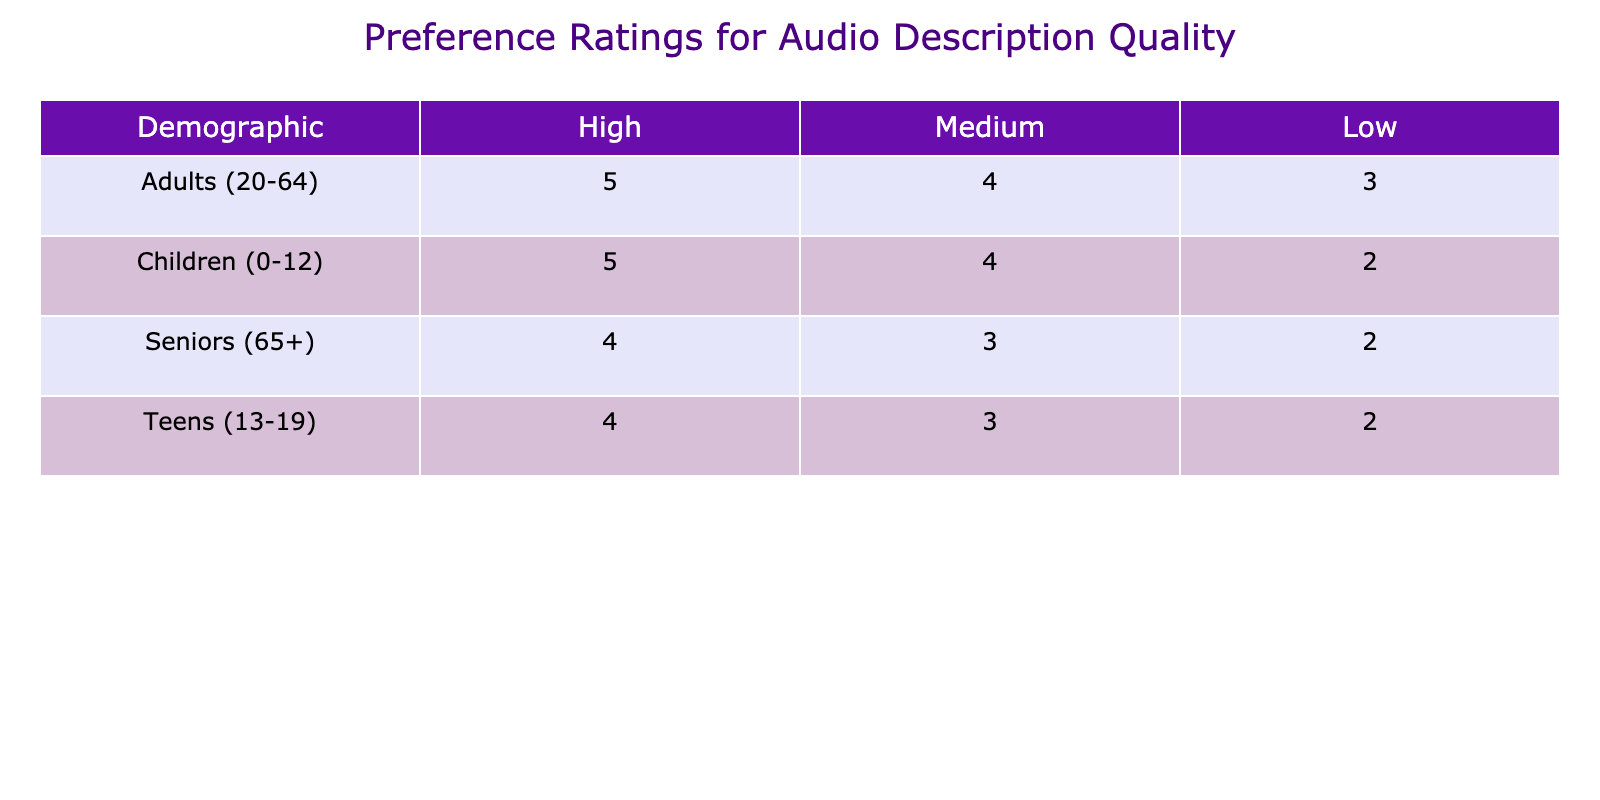What is the preference rating for audio description quality considered high among children? According to the table, for the demographic of children, the preference rating for audio description quality categorized as high is 5.
Answer: 5 What is the lowest preference rating recorded for audio description quality in the seniors' demographic? In the table, the lowest preference rating for audio description quality among seniors is listed under the low category, which is 2.
Answer: 2 What is the average preference rating for audio description quality across all audio description quality levels for adults aged 20-64? To find the average preference rating for adults, we add the relevant ratings: High (5) + Medium (4) + Low (3) = 12. There are 3 ratings, so we divide 12 by 3, resulting in an average of 4.
Answer: 4 Is the preference rating for high audio description quality lower for teens than for adults? The preference rating for high audio description quality for teens is 4, while for adults, it is 5. Since 4 is less than 5, the statement is true.
Answer: Yes What is the difference in preference ratings between medium and low audio description quality for children? For children, the preference rating for medium is 4, and for low is 2. The difference is 4 - 2 = 2.
Answer: 2 Which demographic has the highest preference rating for audio description quality at the medium level? In reviewing the table, adults aged 20-64 have a preference rating of 4 for medium audio description quality, which is higher than the corresponding ratings in other demographics (Children: 4, Teens: 3, Seniors: 3).
Answer: Adults (20-64) What is the sum of preference ratings for low audio description quality across all demographics? From the table, the ratings for low audio description quality are 2 (children) + 2 (teens) + 3 (adults) + 2 (seniors) = 9.
Answer: 9 What percentage of the highest possible preference rating (which is 5) does the medium preference rating have for seniors? The medium preference rating for seniors is 3. To find the percentage of the highest rating, we calculate (3 / 5) * 100, resulting in 60%.
Answer: 60% Is there any demographic where the preference rating for high audio description quality is less than for medium audio description quality? From the table, all demographics show a higher rating for high audio description quality compared to medium: Children (5 vs 4), Teens (4 vs 3), Adults (5 vs 4), and Seniors (4 vs 3). Therefore, the answer is no.
Answer: No 